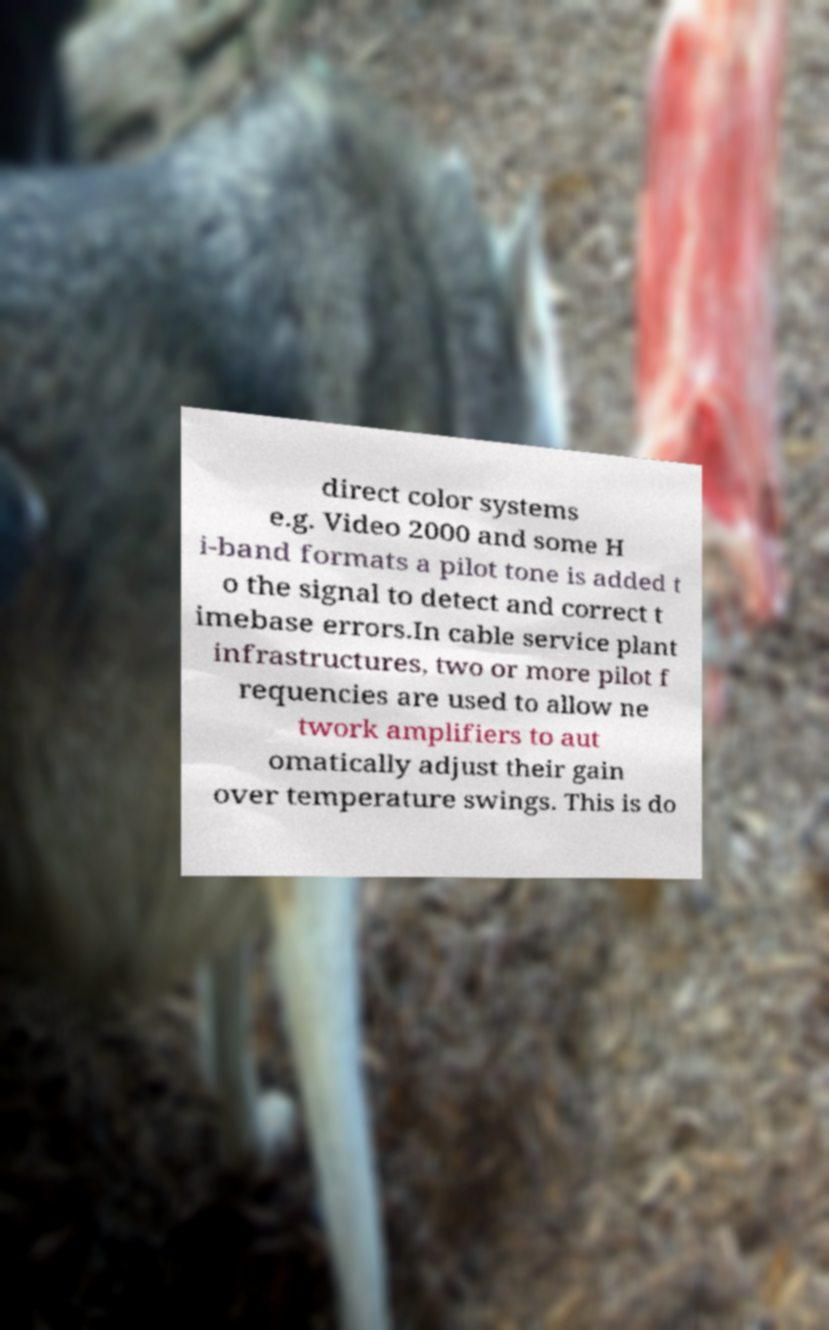Can you read and provide the text displayed in the image?This photo seems to have some interesting text. Can you extract and type it out for me? direct color systems e.g. Video 2000 and some H i-band formats a pilot tone is added t o the signal to detect and correct t imebase errors.In cable service plant infrastructures, two or more pilot f requencies are used to allow ne twork amplifiers to aut omatically adjust their gain over temperature swings. This is do 